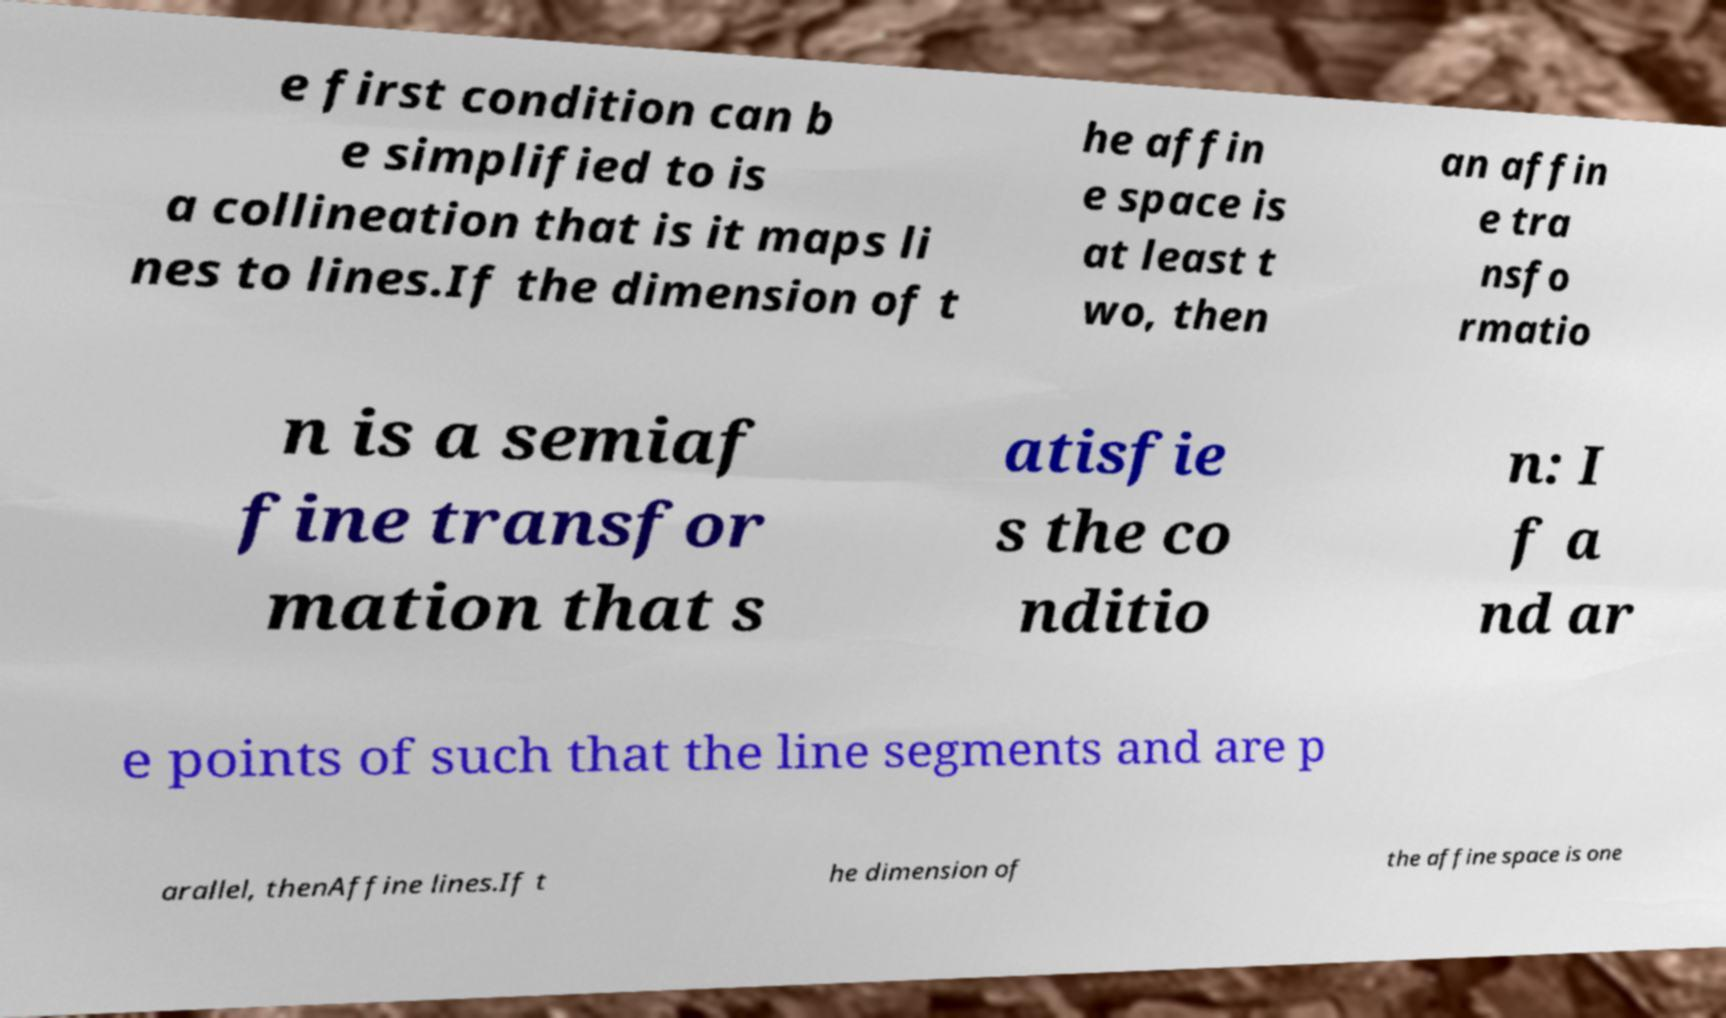Can you read and provide the text displayed in the image?This photo seems to have some interesting text. Can you extract and type it out for me? e first condition can b e simplified to is a collineation that is it maps li nes to lines.If the dimension of t he affin e space is at least t wo, then an affin e tra nsfo rmatio n is a semiaf fine transfor mation that s atisfie s the co nditio n: I f a nd ar e points of such that the line segments and are p arallel, thenAffine lines.If t he dimension of the affine space is one 